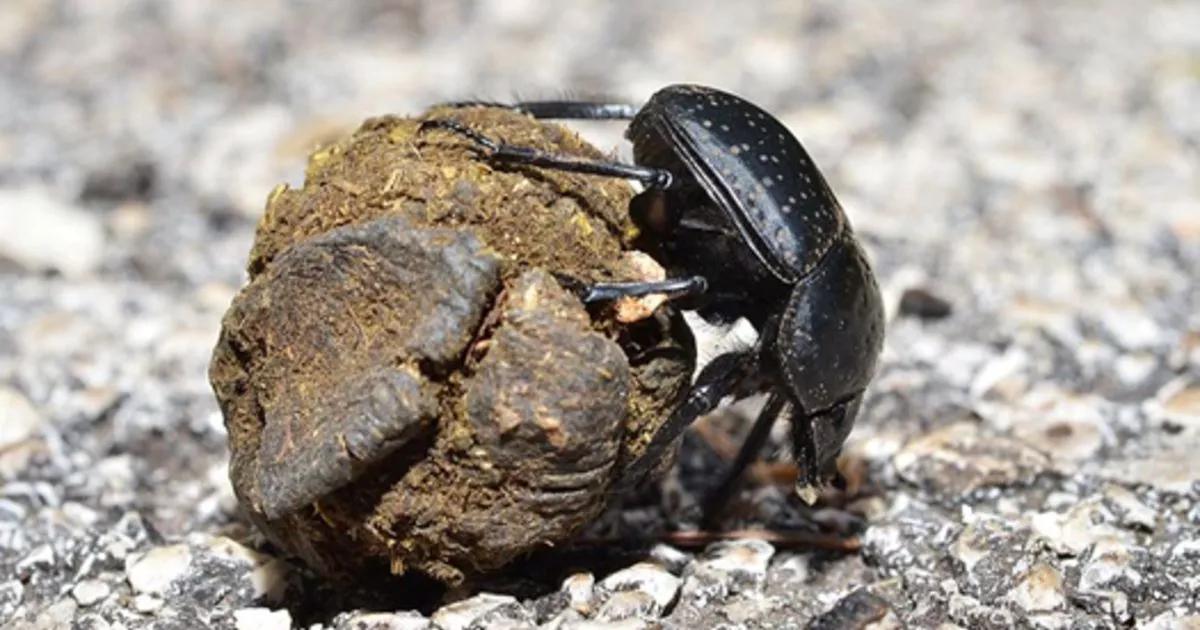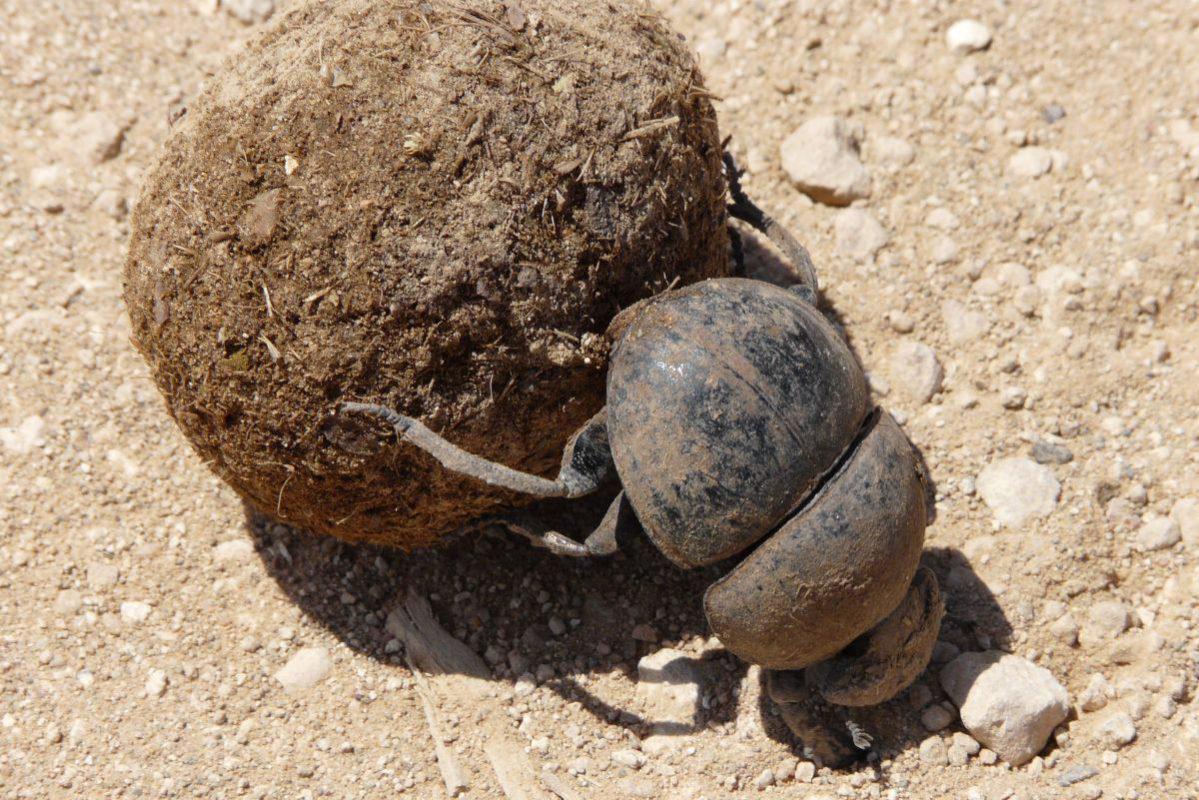The first image is the image on the left, the second image is the image on the right. For the images shown, is this caption "There are multiple beetles near the dung in one of the images." true? Answer yes or no. No. The first image is the image on the left, the second image is the image on the right. Considering the images on both sides, is "Each image includes at least one brown ball and one beetle in contact with it, but no image contains more than two beetles." valid? Answer yes or no. Yes. 